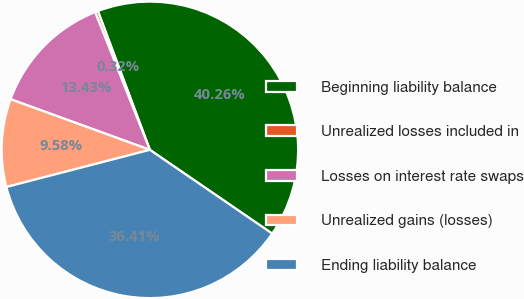<chart> <loc_0><loc_0><loc_500><loc_500><pie_chart><fcel>Beginning liability balance<fcel>Unrealized losses included in<fcel>Losses on interest rate swaps<fcel>Unrealized gains (losses)<fcel>Ending liability balance<nl><fcel>40.26%<fcel>0.32%<fcel>13.43%<fcel>9.58%<fcel>36.41%<nl></chart> 